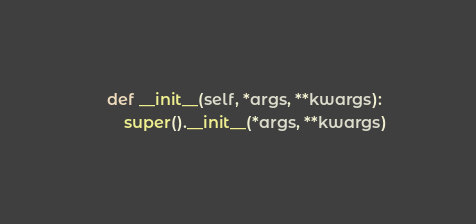<code> <loc_0><loc_0><loc_500><loc_500><_Python_>    def __init__(self, *args, **kwargs):
        super().__init__(*args, **kwargs)
</code> 